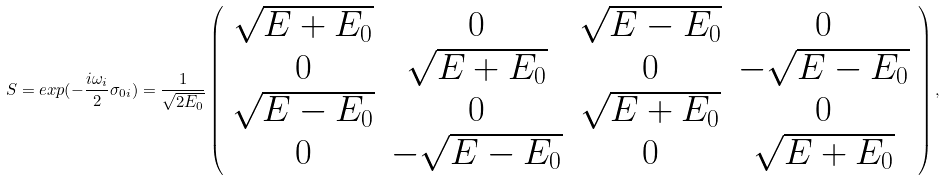Convert formula to latex. <formula><loc_0><loc_0><loc_500><loc_500>S = e x p ( - \frac { i \omega _ { i } } { 2 } \sigma _ { 0 i } ) = \frac { 1 } { \sqrt { 2 E _ { 0 } } } \left ( \begin{array} { c c c c } \sqrt { E + E _ { 0 } } & 0 & \sqrt { E - E _ { 0 } } & 0 \\ 0 & \sqrt { E + E _ { 0 } } & 0 & - \sqrt { E - E _ { 0 } } \\ \sqrt { E - E _ { 0 } } & 0 & \sqrt { E + E _ { 0 } } & 0 \\ 0 & - \sqrt { E - E _ { 0 } } & 0 & \sqrt { E + E _ { 0 } } \end{array} \right ) ,</formula> 